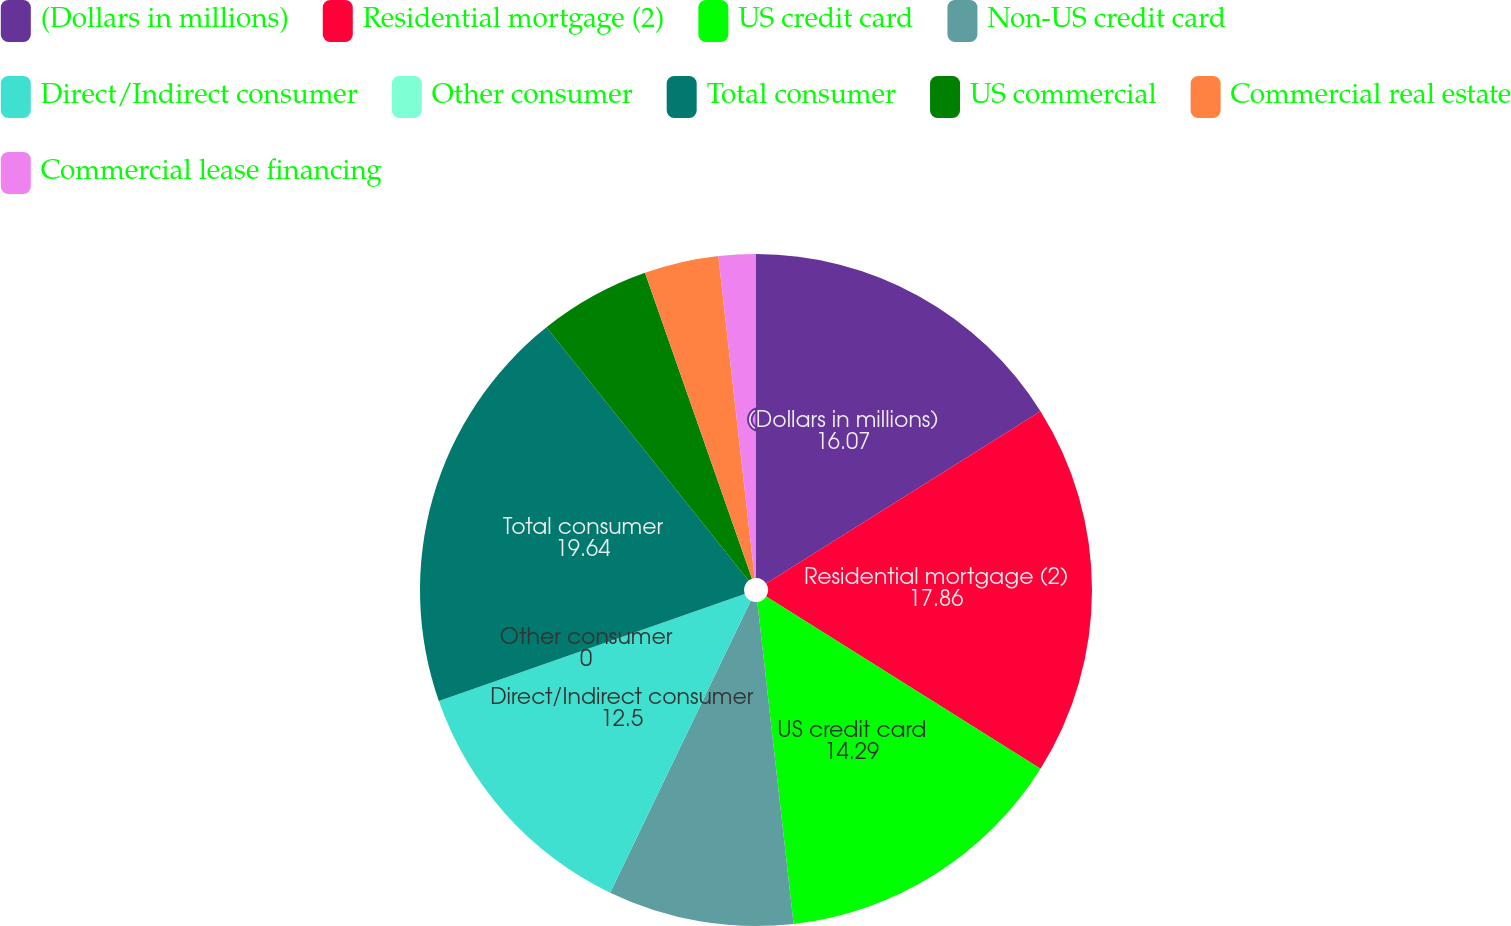Convert chart. <chart><loc_0><loc_0><loc_500><loc_500><pie_chart><fcel>(Dollars in millions)<fcel>Residential mortgage (2)<fcel>US credit card<fcel>Non-US credit card<fcel>Direct/Indirect consumer<fcel>Other consumer<fcel>Total consumer<fcel>US commercial<fcel>Commercial real estate<fcel>Commercial lease financing<nl><fcel>16.07%<fcel>17.86%<fcel>14.29%<fcel>8.93%<fcel>12.5%<fcel>0.0%<fcel>19.64%<fcel>5.36%<fcel>3.57%<fcel>1.79%<nl></chart> 